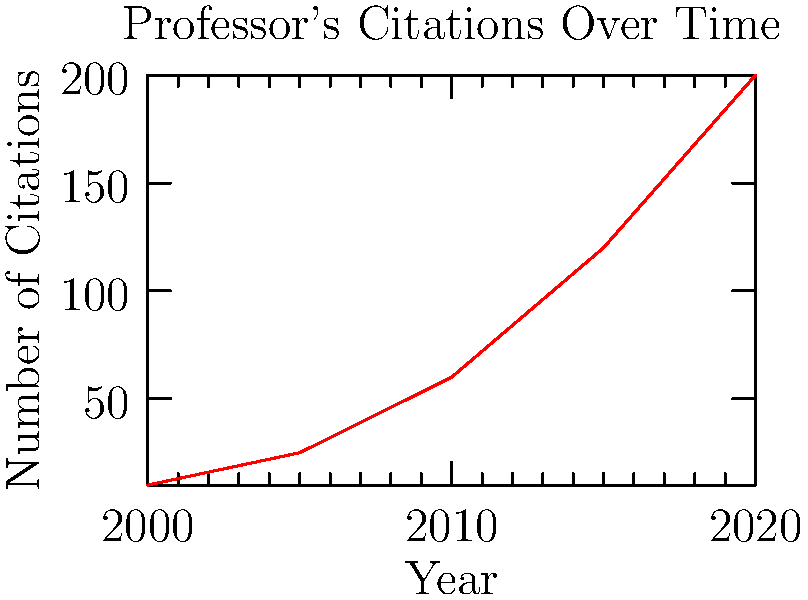Based on the line graph showing the professor's citations over time, what trend can be observed in the impact of their research from 2000 to 2020? To identify the trend in the professor's citations over time:

1. Observe the overall shape of the line: The line is continuously increasing from left to right.

2. Analyze the slope:
   - From 2000 to 2010: The slope is relatively gentle.
   - From 2010 to 2020: The slope becomes steeper.

3. Compare the increase in citations:
   - 2000 to 2010: Citations increased from about 10 to 60 (50 citations in 10 years).
   - 2010 to 2020: Citations increased from about 60 to 200 (140 citations in 10 years).

4. Interpret the data:
   - The consistent upward trend indicates growing recognition of the professor's work.
   - The steeper slope in the latter decade suggests an acceleration in the impact of their research.

5. Conclusion: The trend shows an exponential growth in citations, indicating an increasing impact of the professor's research over time, with a notable acceleration after 2010.
Answer: Exponential growth in citations, with accelerated impact after 2010. 